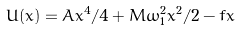Convert formula to latex. <formula><loc_0><loc_0><loc_500><loc_500>U ( x ) = A x ^ { 4 } / 4 + M \omega _ { 1 } ^ { 2 } x ^ { 2 } / 2 - f x</formula> 